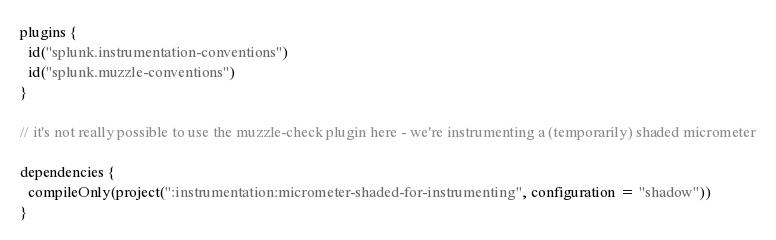Convert code to text. <code><loc_0><loc_0><loc_500><loc_500><_Kotlin_>plugins {
  id("splunk.instrumentation-conventions")
  id("splunk.muzzle-conventions")
}

// it's not really possible to use the muzzle-check plugin here - we're instrumenting a (temporarily) shaded micrometer

dependencies {
  compileOnly(project(":instrumentation:micrometer-shaded-for-instrumenting", configuration = "shadow"))
}
</code> 